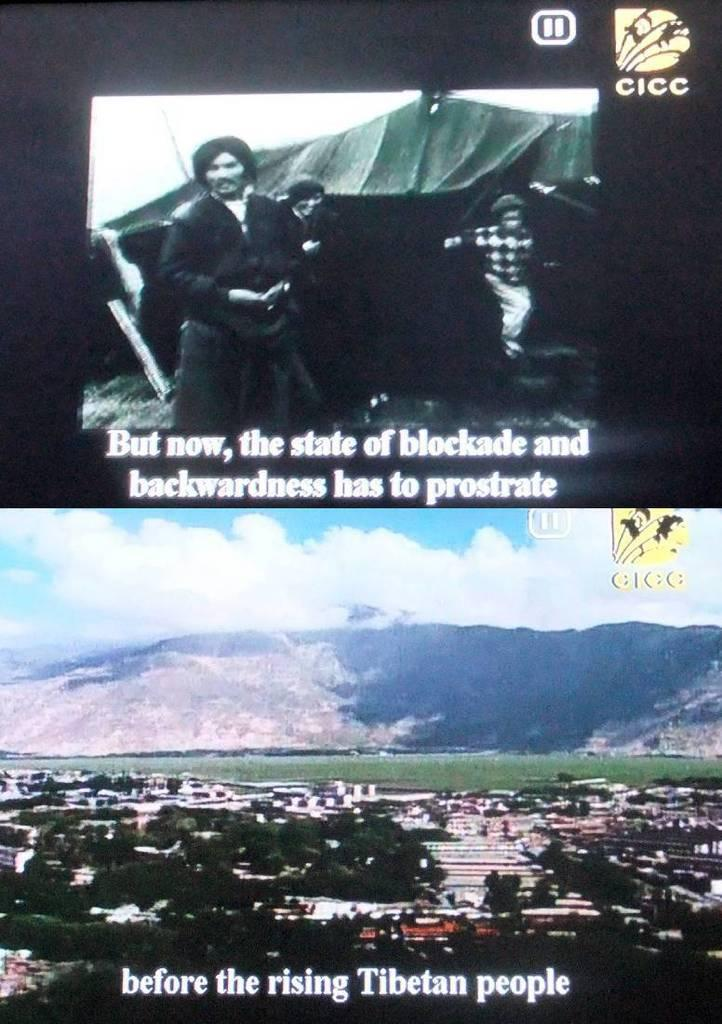<image>
Share a concise interpretation of the image provided. A television program appears to show news relating to a Tibetan uprising. 